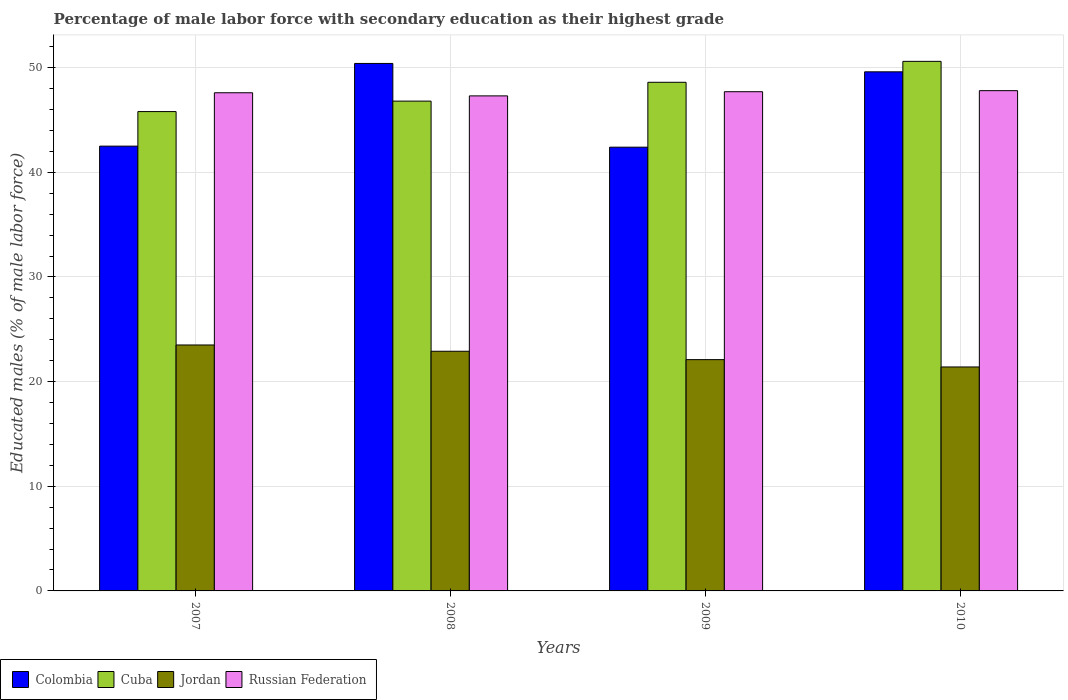How many groups of bars are there?
Ensure brevity in your answer.  4. How many bars are there on the 1st tick from the left?
Your answer should be compact. 4. What is the label of the 1st group of bars from the left?
Make the answer very short. 2007. In how many cases, is the number of bars for a given year not equal to the number of legend labels?
Provide a succinct answer. 0. What is the percentage of male labor force with secondary education in Jordan in 2008?
Provide a short and direct response. 22.9. Across all years, what is the maximum percentage of male labor force with secondary education in Colombia?
Your answer should be compact. 50.4. Across all years, what is the minimum percentage of male labor force with secondary education in Jordan?
Offer a very short reply. 21.4. In which year was the percentage of male labor force with secondary education in Colombia maximum?
Offer a very short reply. 2008. What is the total percentage of male labor force with secondary education in Cuba in the graph?
Ensure brevity in your answer.  191.8. What is the difference between the percentage of male labor force with secondary education in Colombia in 2009 and that in 2010?
Your response must be concise. -7.2. What is the difference between the percentage of male labor force with secondary education in Cuba in 2010 and the percentage of male labor force with secondary education in Jordan in 2009?
Offer a very short reply. 28.5. What is the average percentage of male labor force with secondary education in Cuba per year?
Make the answer very short. 47.95. In the year 2008, what is the difference between the percentage of male labor force with secondary education in Jordan and percentage of male labor force with secondary education in Colombia?
Offer a very short reply. -27.5. What is the ratio of the percentage of male labor force with secondary education in Cuba in 2008 to that in 2010?
Offer a terse response. 0.92. What is the difference between the highest and the second highest percentage of male labor force with secondary education in Jordan?
Your answer should be compact. 0.6. In how many years, is the percentage of male labor force with secondary education in Russian Federation greater than the average percentage of male labor force with secondary education in Russian Federation taken over all years?
Your response must be concise. 2. Is it the case that in every year, the sum of the percentage of male labor force with secondary education in Cuba and percentage of male labor force with secondary education in Colombia is greater than the sum of percentage of male labor force with secondary education in Jordan and percentage of male labor force with secondary education in Russian Federation?
Your response must be concise. No. What does the 4th bar from the left in 2008 represents?
Ensure brevity in your answer.  Russian Federation. What does the 4th bar from the right in 2007 represents?
Give a very brief answer. Colombia. Is it the case that in every year, the sum of the percentage of male labor force with secondary education in Jordan and percentage of male labor force with secondary education in Russian Federation is greater than the percentage of male labor force with secondary education in Cuba?
Your answer should be very brief. Yes. How many bars are there?
Offer a very short reply. 16. How many years are there in the graph?
Your answer should be compact. 4. What is the difference between two consecutive major ticks on the Y-axis?
Your answer should be compact. 10. Does the graph contain any zero values?
Your response must be concise. No. Does the graph contain grids?
Provide a short and direct response. Yes. What is the title of the graph?
Offer a terse response. Percentage of male labor force with secondary education as their highest grade. Does "French Polynesia" appear as one of the legend labels in the graph?
Keep it short and to the point. No. What is the label or title of the X-axis?
Your response must be concise. Years. What is the label or title of the Y-axis?
Offer a terse response. Educated males (% of male labor force). What is the Educated males (% of male labor force) in Colombia in 2007?
Provide a succinct answer. 42.5. What is the Educated males (% of male labor force) in Cuba in 2007?
Provide a succinct answer. 45.8. What is the Educated males (% of male labor force) in Russian Federation in 2007?
Keep it short and to the point. 47.6. What is the Educated males (% of male labor force) in Colombia in 2008?
Your response must be concise. 50.4. What is the Educated males (% of male labor force) of Cuba in 2008?
Offer a very short reply. 46.8. What is the Educated males (% of male labor force) of Jordan in 2008?
Provide a short and direct response. 22.9. What is the Educated males (% of male labor force) in Russian Federation in 2008?
Make the answer very short. 47.3. What is the Educated males (% of male labor force) in Colombia in 2009?
Your answer should be very brief. 42.4. What is the Educated males (% of male labor force) in Cuba in 2009?
Provide a succinct answer. 48.6. What is the Educated males (% of male labor force) of Jordan in 2009?
Ensure brevity in your answer.  22.1. What is the Educated males (% of male labor force) in Russian Federation in 2009?
Offer a very short reply. 47.7. What is the Educated males (% of male labor force) of Colombia in 2010?
Offer a terse response. 49.6. What is the Educated males (% of male labor force) of Cuba in 2010?
Keep it short and to the point. 50.6. What is the Educated males (% of male labor force) of Jordan in 2010?
Offer a terse response. 21.4. What is the Educated males (% of male labor force) in Russian Federation in 2010?
Provide a succinct answer. 47.8. Across all years, what is the maximum Educated males (% of male labor force) in Colombia?
Offer a terse response. 50.4. Across all years, what is the maximum Educated males (% of male labor force) in Cuba?
Give a very brief answer. 50.6. Across all years, what is the maximum Educated males (% of male labor force) in Jordan?
Provide a short and direct response. 23.5. Across all years, what is the maximum Educated males (% of male labor force) of Russian Federation?
Your answer should be very brief. 47.8. Across all years, what is the minimum Educated males (% of male labor force) in Colombia?
Keep it short and to the point. 42.4. Across all years, what is the minimum Educated males (% of male labor force) of Cuba?
Give a very brief answer. 45.8. Across all years, what is the minimum Educated males (% of male labor force) of Jordan?
Your answer should be very brief. 21.4. Across all years, what is the minimum Educated males (% of male labor force) in Russian Federation?
Your response must be concise. 47.3. What is the total Educated males (% of male labor force) of Colombia in the graph?
Provide a succinct answer. 184.9. What is the total Educated males (% of male labor force) in Cuba in the graph?
Your answer should be compact. 191.8. What is the total Educated males (% of male labor force) of Jordan in the graph?
Ensure brevity in your answer.  89.9. What is the total Educated males (% of male labor force) of Russian Federation in the graph?
Offer a terse response. 190.4. What is the difference between the Educated males (% of male labor force) of Colombia in 2007 and that in 2008?
Give a very brief answer. -7.9. What is the difference between the Educated males (% of male labor force) in Colombia in 2007 and that in 2009?
Your response must be concise. 0.1. What is the difference between the Educated males (% of male labor force) of Cuba in 2007 and that in 2009?
Your answer should be compact. -2.8. What is the difference between the Educated males (% of male labor force) in Jordan in 2007 and that in 2009?
Your response must be concise. 1.4. What is the difference between the Educated males (% of male labor force) in Russian Federation in 2007 and that in 2009?
Your answer should be compact. -0.1. What is the difference between the Educated males (% of male labor force) of Cuba in 2007 and that in 2010?
Offer a terse response. -4.8. What is the difference between the Educated males (% of male labor force) of Cuba in 2008 and that in 2009?
Provide a short and direct response. -1.8. What is the difference between the Educated males (% of male labor force) in Jordan in 2008 and that in 2009?
Make the answer very short. 0.8. What is the difference between the Educated males (% of male labor force) in Colombia in 2008 and that in 2010?
Offer a terse response. 0.8. What is the difference between the Educated males (% of male labor force) of Colombia in 2009 and that in 2010?
Keep it short and to the point. -7.2. What is the difference between the Educated males (% of male labor force) in Cuba in 2009 and that in 2010?
Provide a short and direct response. -2. What is the difference between the Educated males (% of male labor force) in Jordan in 2009 and that in 2010?
Offer a terse response. 0.7. What is the difference between the Educated males (% of male labor force) of Russian Federation in 2009 and that in 2010?
Provide a succinct answer. -0.1. What is the difference between the Educated males (% of male labor force) in Colombia in 2007 and the Educated males (% of male labor force) in Jordan in 2008?
Your response must be concise. 19.6. What is the difference between the Educated males (% of male labor force) in Cuba in 2007 and the Educated males (% of male labor force) in Jordan in 2008?
Offer a very short reply. 22.9. What is the difference between the Educated males (% of male labor force) of Cuba in 2007 and the Educated males (% of male labor force) of Russian Federation in 2008?
Your answer should be very brief. -1.5. What is the difference between the Educated males (% of male labor force) of Jordan in 2007 and the Educated males (% of male labor force) of Russian Federation in 2008?
Your response must be concise. -23.8. What is the difference between the Educated males (% of male labor force) in Colombia in 2007 and the Educated males (% of male labor force) in Cuba in 2009?
Keep it short and to the point. -6.1. What is the difference between the Educated males (% of male labor force) in Colombia in 2007 and the Educated males (% of male labor force) in Jordan in 2009?
Provide a succinct answer. 20.4. What is the difference between the Educated males (% of male labor force) in Colombia in 2007 and the Educated males (% of male labor force) in Russian Federation in 2009?
Your answer should be compact. -5.2. What is the difference between the Educated males (% of male labor force) of Cuba in 2007 and the Educated males (% of male labor force) of Jordan in 2009?
Provide a succinct answer. 23.7. What is the difference between the Educated males (% of male labor force) in Jordan in 2007 and the Educated males (% of male labor force) in Russian Federation in 2009?
Ensure brevity in your answer.  -24.2. What is the difference between the Educated males (% of male labor force) of Colombia in 2007 and the Educated males (% of male labor force) of Cuba in 2010?
Your answer should be compact. -8.1. What is the difference between the Educated males (% of male labor force) of Colombia in 2007 and the Educated males (% of male labor force) of Jordan in 2010?
Offer a very short reply. 21.1. What is the difference between the Educated males (% of male labor force) of Cuba in 2007 and the Educated males (% of male labor force) of Jordan in 2010?
Provide a succinct answer. 24.4. What is the difference between the Educated males (% of male labor force) in Cuba in 2007 and the Educated males (% of male labor force) in Russian Federation in 2010?
Make the answer very short. -2. What is the difference between the Educated males (% of male labor force) in Jordan in 2007 and the Educated males (% of male labor force) in Russian Federation in 2010?
Offer a terse response. -24.3. What is the difference between the Educated males (% of male labor force) of Colombia in 2008 and the Educated males (% of male labor force) of Jordan in 2009?
Provide a short and direct response. 28.3. What is the difference between the Educated males (% of male labor force) in Cuba in 2008 and the Educated males (% of male labor force) in Jordan in 2009?
Offer a terse response. 24.7. What is the difference between the Educated males (% of male labor force) of Jordan in 2008 and the Educated males (% of male labor force) of Russian Federation in 2009?
Your response must be concise. -24.8. What is the difference between the Educated males (% of male labor force) in Colombia in 2008 and the Educated males (% of male labor force) in Cuba in 2010?
Offer a terse response. -0.2. What is the difference between the Educated males (% of male labor force) of Colombia in 2008 and the Educated males (% of male labor force) of Russian Federation in 2010?
Your answer should be very brief. 2.6. What is the difference between the Educated males (% of male labor force) in Cuba in 2008 and the Educated males (% of male labor force) in Jordan in 2010?
Offer a very short reply. 25.4. What is the difference between the Educated males (% of male labor force) in Jordan in 2008 and the Educated males (% of male labor force) in Russian Federation in 2010?
Make the answer very short. -24.9. What is the difference between the Educated males (% of male labor force) in Colombia in 2009 and the Educated males (% of male labor force) in Cuba in 2010?
Provide a short and direct response. -8.2. What is the difference between the Educated males (% of male labor force) of Colombia in 2009 and the Educated males (% of male labor force) of Jordan in 2010?
Make the answer very short. 21. What is the difference between the Educated males (% of male labor force) of Colombia in 2009 and the Educated males (% of male labor force) of Russian Federation in 2010?
Offer a very short reply. -5.4. What is the difference between the Educated males (% of male labor force) in Cuba in 2009 and the Educated males (% of male labor force) in Jordan in 2010?
Offer a terse response. 27.2. What is the difference between the Educated males (% of male labor force) in Jordan in 2009 and the Educated males (% of male labor force) in Russian Federation in 2010?
Give a very brief answer. -25.7. What is the average Educated males (% of male labor force) of Colombia per year?
Make the answer very short. 46.23. What is the average Educated males (% of male labor force) in Cuba per year?
Offer a terse response. 47.95. What is the average Educated males (% of male labor force) of Jordan per year?
Offer a very short reply. 22.48. What is the average Educated males (% of male labor force) in Russian Federation per year?
Ensure brevity in your answer.  47.6. In the year 2007, what is the difference between the Educated males (% of male labor force) in Colombia and Educated males (% of male labor force) in Jordan?
Your answer should be very brief. 19. In the year 2007, what is the difference between the Educated males (% of male labor force) of Colombia and Educated males (% of male labor force) of Russian Federation?
Your answer should be compact. -5.1. In the year 2007, what is the difference between the Educated males (% of male labor force) of Cuba and Educated males (% of male labor force) of Jordan?
Make the answer very short. 22.3. In the year 2007, what is the difference between the Educated males (% of male labor force) in Cuba and Educated males (% of male labor force) in Russian Federation?
Your answer should be very brief. -1.8. In the year 2007, what is the difference between the Educated males (% of male labor force) of Jordan and Educated males (% of male labor force) of Russian Federation?
Offer a very short reply. -24.1. In the year 2008, what is the difference between the Educated males (% of male labor force) in Colombia and Educated males (% of male labor force) in Cuba?
Keep it short and to the point. 3.6. In the year 2008, what is the difference between the Educated males (% of male labor force) of Cuba and Educated males (% of male labor force) of Jordan?
Your answer should be very brief. 23.9. In the year 2008, what is the difference between the Educated males (% of male labor force) in Cuba and Educated males (% of male labor force) in Russian Federation?
Your response must be concise. -0.5. In the year 2008, what is the difference between the Educated males (% of male labor force) of Jordan and Educated males (% of male labor force) of Russian Federation?
Make the answer very short. -24.4. In the year 2009, what is the difference between the Educated males (% of male labor force) of Colombia and Educated males (% of male labor force) of Jordan?
Your answer should be compact. 20.3. In the year 2009, what is the difference between the Educated males (% of male labor force) of Colombia and Educated males (% of male labor force) of Russian Federation?
Ensure brevity in your answer.  -5.3. In the year 2009, what is the difference between the Educated males (% of male labor force) in Cuba and Educated males (% of male labor force) in Russian Federation?
Offer a very short reply. 0.9. In the year 2009, what is the difference between the Educated males (% of male labor force) of Jordan and Educated males (% of male labor force) of Russian Federation?
Your answer should be compact. -25.6. In the year 2010, what is the difference between the Educated males (% of male labor force) in Colombia and Educated males (% of male labor force) in Jordan?
Offer a terse response. 28.2. In the year 2010, what is the difference between the Educated males (% of male labor force) in Cuba and Educated males (% of male labor force) in Jordan?
Give a very brief answer. 29.2. In the year 2010, what is the difference between the Educated males (% of male labor force) of Jordan and Educated males (% of male labor force) of Russian Federation?
Your answer should be compact. -26.4. What is the ratio of the Educated males (% of male labor force) in Colombia in 2007 to that in 2008?
Make the answer very short. 0.84. What is the ratio of the Educated males (% of male labor force) of Cuba in 2007 to that in 2008?
Make the answer very short. 0.98. What is the ratio of the Educated males (% of male labor force) of Jordan in 2007 to that in 2008?
Make the answer very short. 1.03. What is the ratio of the Educated males (% of male labor force) of Colombia in 2007 to that in 2009?
Provide a short and direct response. 1. What is the ratio of the Educated males (% of male labor force) of Cuba in 2007 to that in 2009?
Offer a very short reply. 0.94. What is the ratio of the Educated males (% of male labor force) of Jordan in 2007 to that in 2009?
Provide a short and direct response. 1.06. What is the ratio of the Educated males (% of male labor force) of Russian Federation in 2007 to that in 2009?
Give a very brief answer. 1. What is the ratio of the Educated males (% of male labor force) of Colombia in 2007 to that in 2010?
Keep it short and to the point. 0.86. What is the ratio of the Educated males (% of male labor force) in Cuba in 2007 to that in 2010?
Offer a terse response. 0.91. What is the ratio of the Educated males (% of male labor force) in Jordan in 2007 to that in 2010?
Provide a short and direct response. 1.1. What is the ratio of the Educated males (% of male labor force) in Russian Federation in 2007 to that in 2010?
Provide a succinct answer. 1. What is the ratio of the Educated males (% of male labor force) in Colombia in 2008 to that in 2009?
Make the answer very short. 1.19. What is the ratio of the Educated males (% of male labor force) of Cuba in 2008 to that in 2009?
Provide a succinct answer. 0.96. What is the ratio of the Educated males (% of male labor force) of Jordan in 2008 to that in 2009?
Keep it short and to the point. 1.04. What is the ratio of the Educated males (% of male labor force) of Colombia in 2008 to that in 2010?
Give a very brief answer. 1.02. What is the ratio of the Educated males (% of male labor force) of Cuba in 2008 to that in 2010?
Offer a very short reply. 0.92. What is the ratio of the Educated males (% of male labor force) in Jordan in 2008 to that in 2010?
Your response must be concise. 1.07. What is the ratio of the Educated males (% of male labor force) in Colombia in 2009 to that in 2010?
Ensure brevity in your answer.  0.85. What is the ratio of the Educated males (% of male labor force) of Cuba in 2009 to that in 2010?
Provide a short and direct response. 0.96. What is the ratio of the Educated males (% of male labor force) in Jordan in 2009 to that in 2010?
Provide a succinct answer. 1.03. What is the ratio of the Educated males (% of male labor force) in Russian Federation in 2009 to that in 2010?
Provide a succinct answer. 1. What is the difference between the highest and the second highest Educated males (% of male labor force) in Colombia?
Offer a very short reply. 0.8. What is the difference between the highest and the second highest Educated males (% of male labor force) of Cuba?
Make the answer very short. 2. What is the difference between the highest and the second highest Educated males (% of male labor force) of Jordan?
Make the answer very short. 0.6. What is the difference between the highest and the second highest Educated males (% of male labor force) in Russian Federation?
Offer a very short reply. 0.1. What is the difference between the highest and the lowest Educated males (% of male labor force) of Colombia?
Offer a very short reply. 8. 